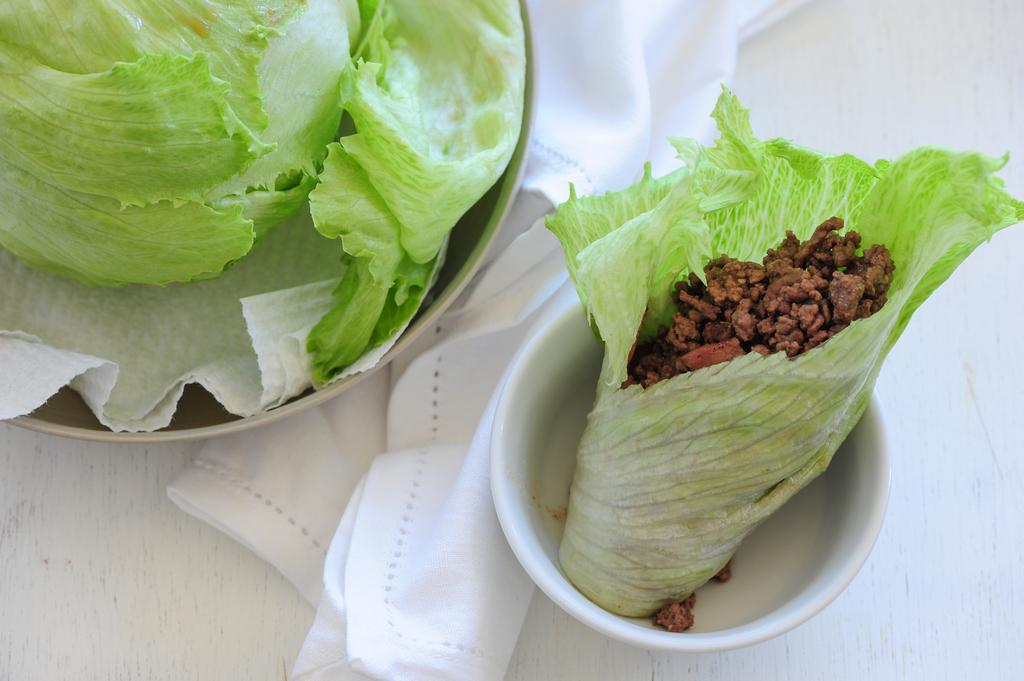What is the color of the table in the image? The table in the image is white. What is placed on the table? There is a white cloth on the table. How many bowls are on the table? There are two bowls on the table. What is inside the bowls? The bowls contain cauliflower leaves. What else can be seen in the image? There is tissue paper in the image. What type of class is being held in the image? There is no class or any indication of a class being held in the image. 